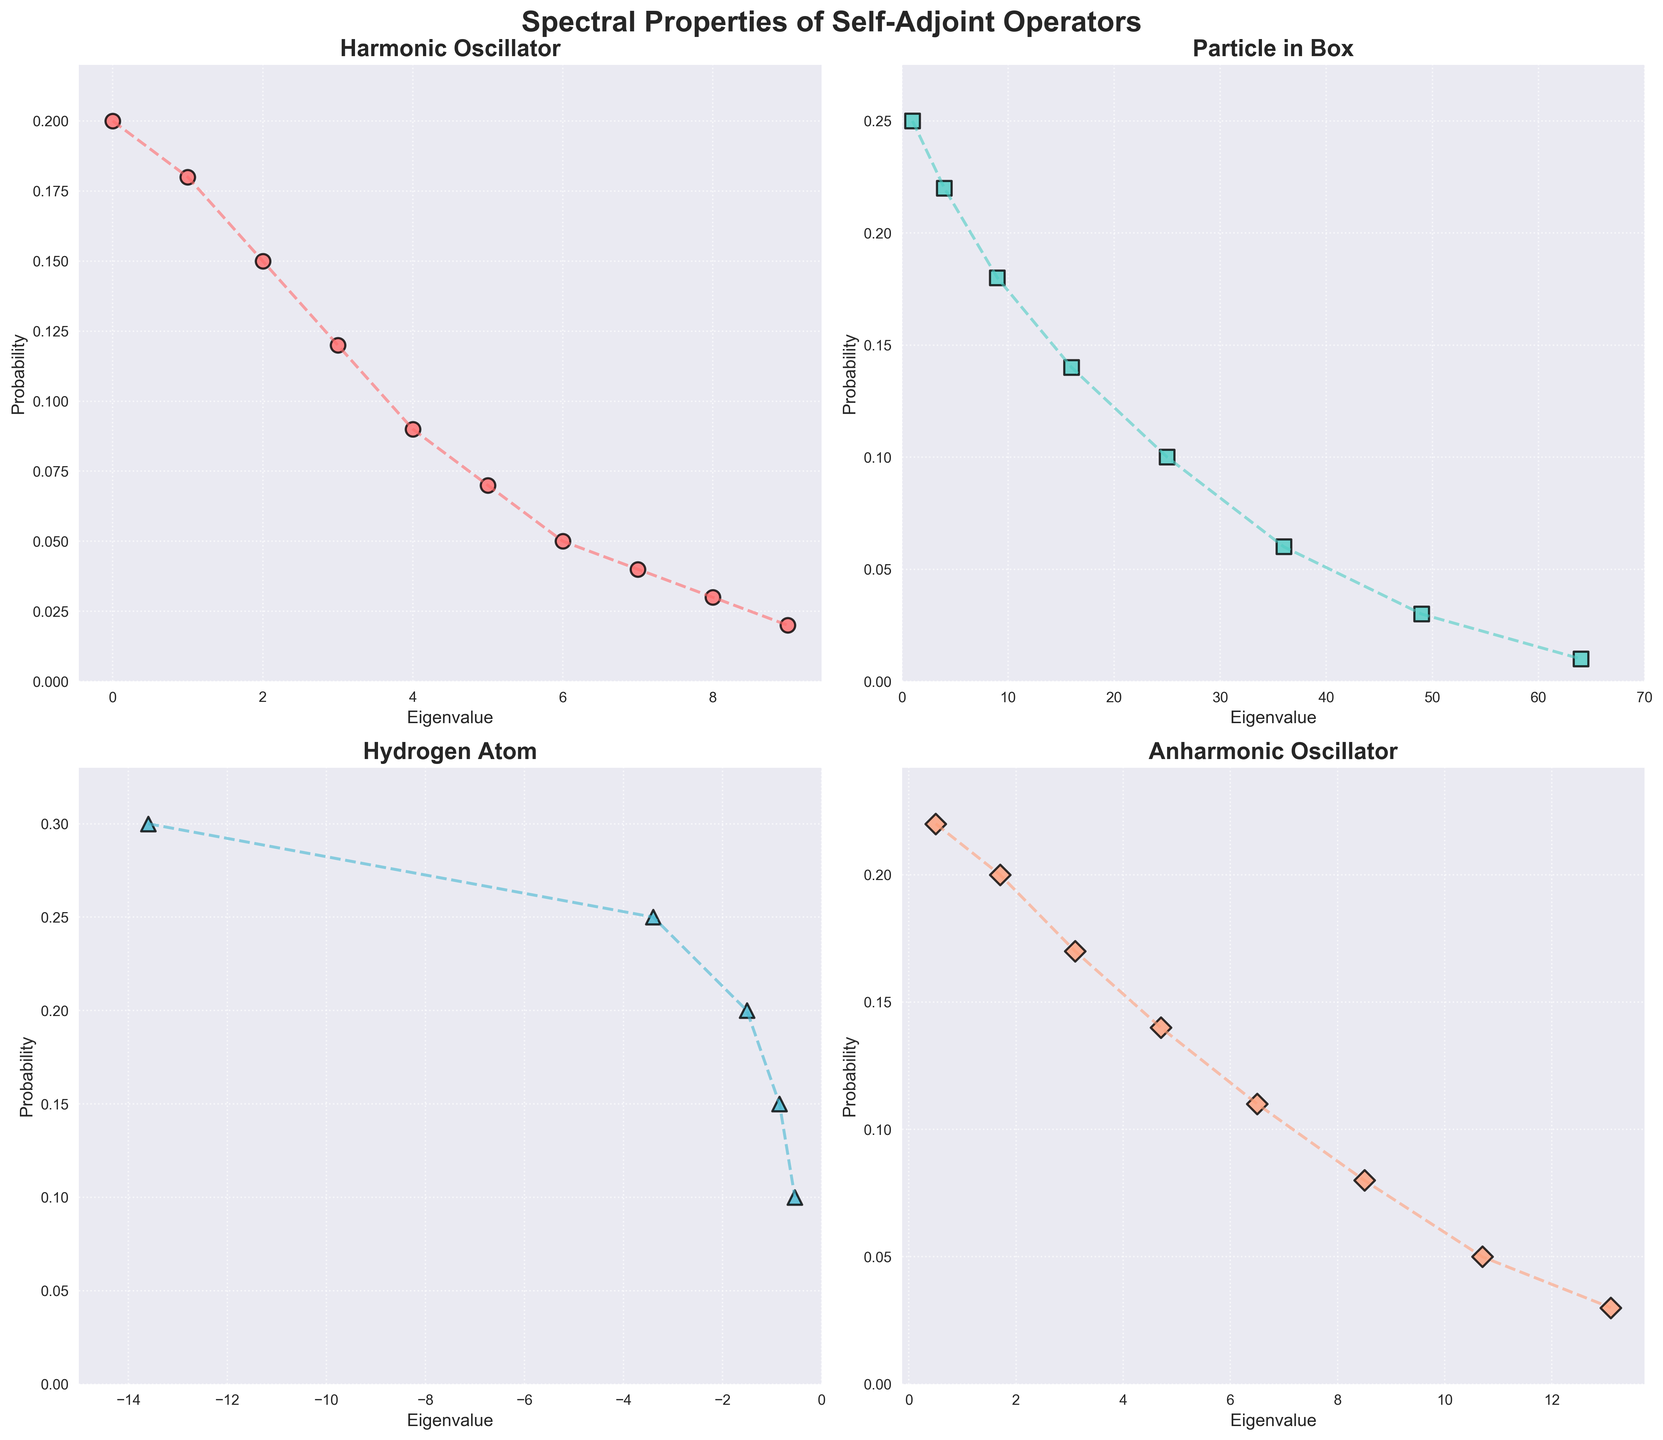Is the first eigenvalue of the Harmonic Oscillator greater than the second eigenvalue of the Hydrogen Atom? The first eigenvalue of the Harmonic Oscillator is 0. The second eigenvalue of the Hydrogen Atom is -3.4. Since 0 is greater than -3.4, the first eigenvalue of the Harmonic Oscillator is greater than the second eigenvalue of the Hydrogen Atom.
Answer: Yes Which operator has the highest probability for its lowest eigenvalue? For the Harmonic Oscillator, the probability for the lowest eigenvalue is 0.2. For the Particle in Box, it is 0.25. For the Hydrogen Atom, it is 0.3. For the Anharmonic Oscillator, it is 0.22. The highest value among these is 0.3, which corresponds to the Hydrogen Atom.
Answer: Hydrogen Atom What is the difference between the highest and the lowest eigenvalues of the Particle in the Box operator? The highest eigenvalue for the Particle in Box operator is 64 and the lowest eigenvalue is 1. The difference between these two values is 64 - 1 = 63.
Answer: 63 Order the operators by their highest eigenvalue. The highest eigenvalue for Harmonic Oscillator is 9; for Particle in Box, it is 64; for Hydrogen Atom, it is -0.54; and for Anharmonic Oscillator, it is 13.1. Ordering them by the highest eigenvalue: Particle in Box, Anharmonic Oscillator, Harmonic Oscillator, Hydrogen Atom.
Answer: Particle in Box > Anharmonic Oscillator > Harmonic Oscillator > Hydrogen Atom Which operator shows a decreasing trend in probability with increasing eigenvalues, and how is this visually represented? The Harmonic Oscillator and Anharmonic Oscillator show a clear decreasing trend in probability with increasing eigenvalues, as indicated by the scatter and line plots with downward sloping patterns.
Answer: Harmonic Oscillator and Anharmonic Oscillator What is the combined probability of the first three eigenvalues of the Hydrogen Atom? The probabilities of the first three eigenvalues are 0.3, 0.25, and 0.2, respectively. Summing these gives 0.3 + 0.25 + 0.2 = 0.75.
Answer: 0.75 Compare the probabilities of the second eigenvalue of the Harmonic Oscillator with the second eigenvalue of the Anharmonic Oscillator. Which is higher? The probability of the second eigenvalue of the Harmonic Oscillator (eigenvalue 1) is 0.18. The probability of the second eigenvalue of the Anharmonic Oscillator (eigenvalue 1.7) is 0.2. 0.2 is higher than 0.18.
Answer: Anharmonic Oscillator What are the colors used for the Harmonic Oscillator and Particle in Box in the plots? The Harmonic Oscillator is represented by points and lines in red, while the Particle in Box is represented by points and lines in a turquoise color.
Answer: Red and turquoise 